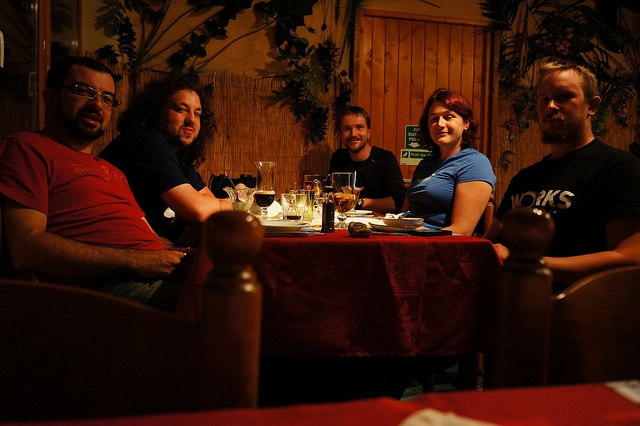Describe the objects in this image and their specific colors. I can see chair in black, maroon, brown, and tan tones, dining table in black and maroon tones, people in black, maroon, and brown tones, people in black, maroon, and brown tones, and chair in black, maroon, and olive tones in this image. 